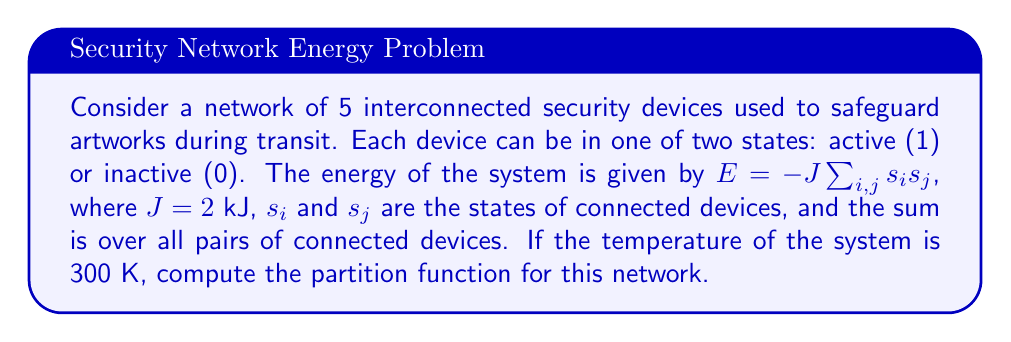Can you answer this question? To compute the partition function, we follow these steps:

1) The partition function is defined as:
   $$Z = \sum_{\text{all states}} e^{-\beta E}$$
   where $\beta = \frac{1}{k_B T}$, $k_B$ is Boltzmann's constant, and $T$ is temperature.

2) Calculate $\beta$:
   $$\beta = \frac{1}{(1.380649 \times 10^{-23} \text{ J/K})(300 \text{ K})} = 2.4151 \times 10^{20} \text{ J}^{-1}$$

3) For 5 devices, there are $2^5 = 32$ possible states.

4) For each state, we need to calculate the energy and then $e^{-\beta E}$.

5) The energy depends on the number of connections between active devices. In a fully connected network of 5 devices, there are 10 connections.

6) The possible energies are:
   - All devices inactive (0 active connections): $E = 0$
   - 1 device active (0 active connections): $E = 0$
   - 2 devices active (1 active connection): $E = -2J = -4$ kJ
   - 3 devices active (3 active connections): $E = -6J = -12$ kJ
   - 4 devices active (6 active connections): $E = -12J = -24$ kJ
   - All devices active (10 active connections): $E = -20J = -40$ kJ

7) Now, we calculate $e^{-\beta E}$ for each energy level:
   - $E = 0$: $e^{-\beta E} = 1$
   - $E = -4$ kJ: $e^{-\beta E} = e^{9.6604 \times 10^{17}} \approx 10^{4.19 \times 10^{17}}$
   - $E = -12$ kJ: $e^{-\beta E} = e^{2.8981 \times 10^{18}} \approx 10^{1.26 \times 10^{18}}$
   - $E = -24$ kJ: $e^{-\beta E} = e^{5.7962 \times 10^{18}} \approx 10^{2.52 \times 10^{18}}$
   - $E = -40$ kJ: $e^{-\beta E} = e^{9.6604 \times 10^{18}} \approx 10^{4.19 \times 10^{18}}$

8) Count the number of states for each energy level:
   - $E = 0$: 1 state (all inactive) + 5 states (1 active) = 6 states
   - $E = -4$ kJ: 10 states (2 active)
   - $E = -12$ kJ: 10 states (3 active)
   - $E = -24$ kJ: 5 states (4 active)
   - $E = -40$ kJ: 1 state (all active)

9) Sum up all the terms:
   $$Z = 6 + 10 \times 10^{4.19 \times 10^{17}} + 10 \times 10^{1.26 \times 10^{18}} + 5 \times 10^{2.52 \times 10^{18}} + 10^{4.19 \times 10^{18}}$$

10) The largest term dominates, so we can approximate:
    $$Z \approx 10^{4.19 \times 10^{18}}$$
Answer: $Z \approx 10^{4.19 \times 10^{18}}$ 